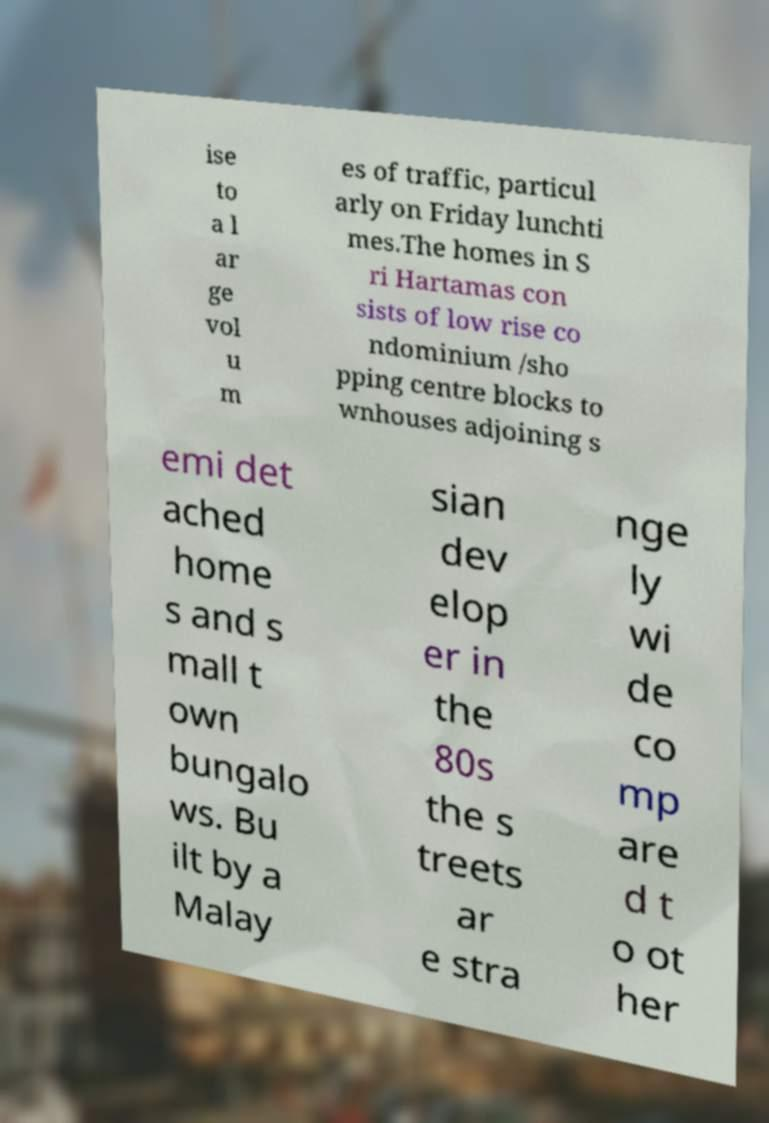Can you accurately transcribe the text from the provided image for me? ise to a l ar ge vol u m es of traffic, particul arly on Friday lunchti mes.The homes in S ri Hartamas con sists of low rise co ndominium /sho pping centre blocks to wnhouses adjoining s emi det ached home s and s mall t own bungalo ws. Bu ilt by a Malay sian dev elop er in the 80s the s treets ar e stra nge ly wi de co mp are d t o ot her 